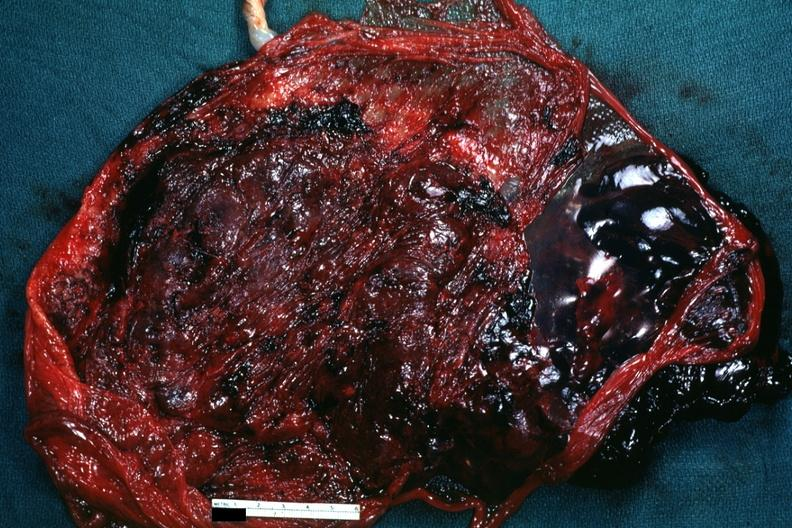where does this belong to?
Answer the question using a single word or phrase. Female reproductive system 